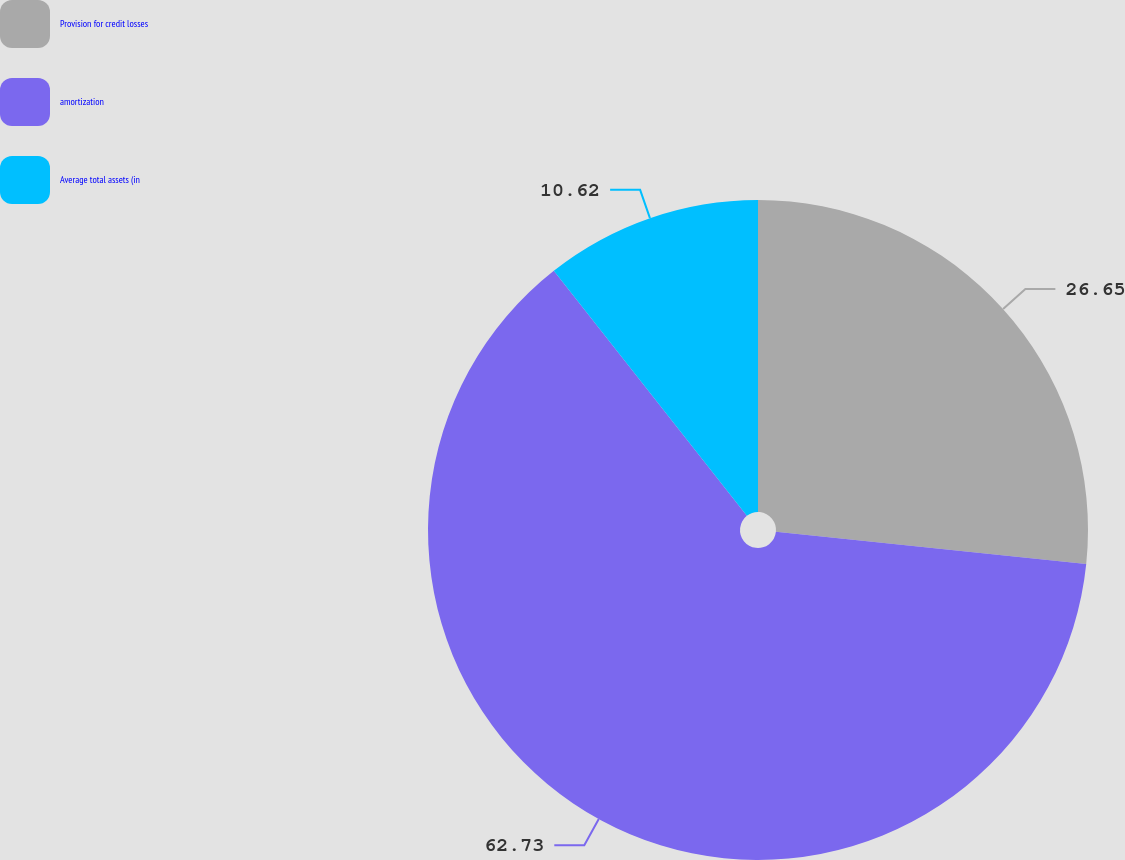Convert chart to OTSL. <chart><loc_0><loc_0><loc_500><loc_500><pie_chart><fcel>Provision for credit losses<fcel>amortization<fcel>Average total assets (in<nl><fcel>26.65%<fcel>62.74%<fcel>10.62%<nl></chart> 